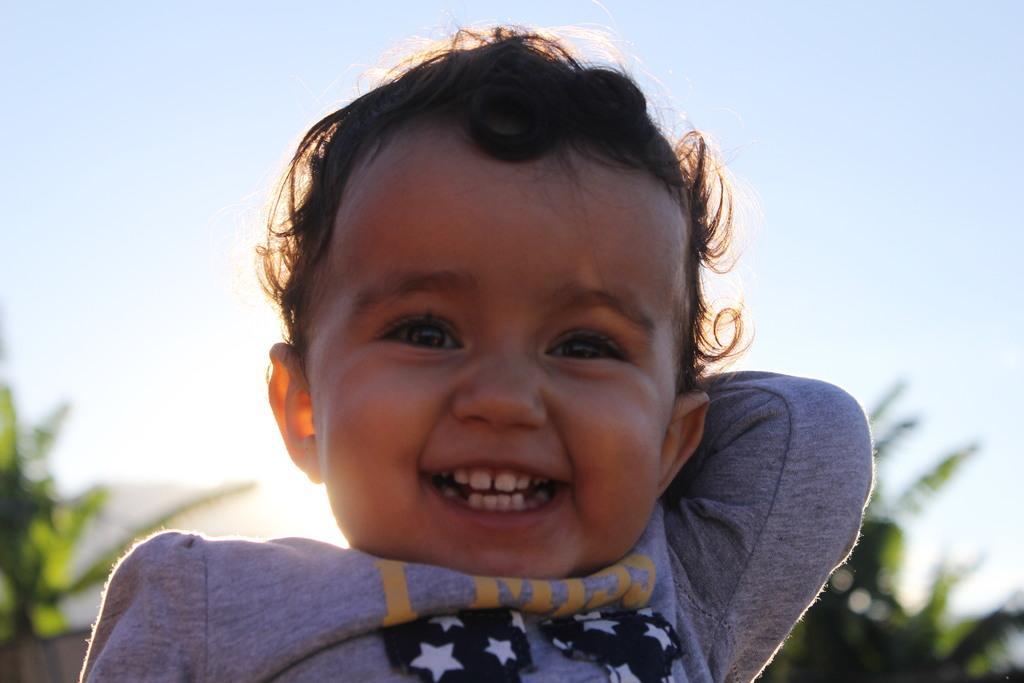Could you give a brief overview of what you see in this image? In this picture there is a kid smiling. The background is blurred. In the background there are trees and sun. Sky is clear. 